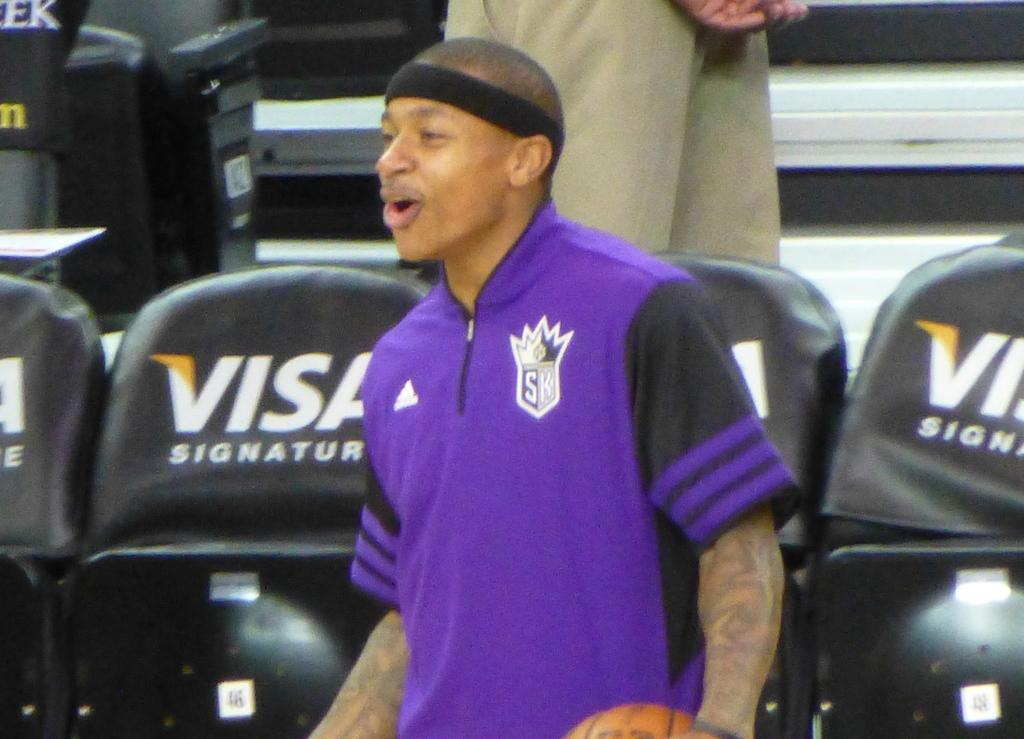<image>
Describe the image concisely. A basketball player stands in a stadium sponsored by Visa. 